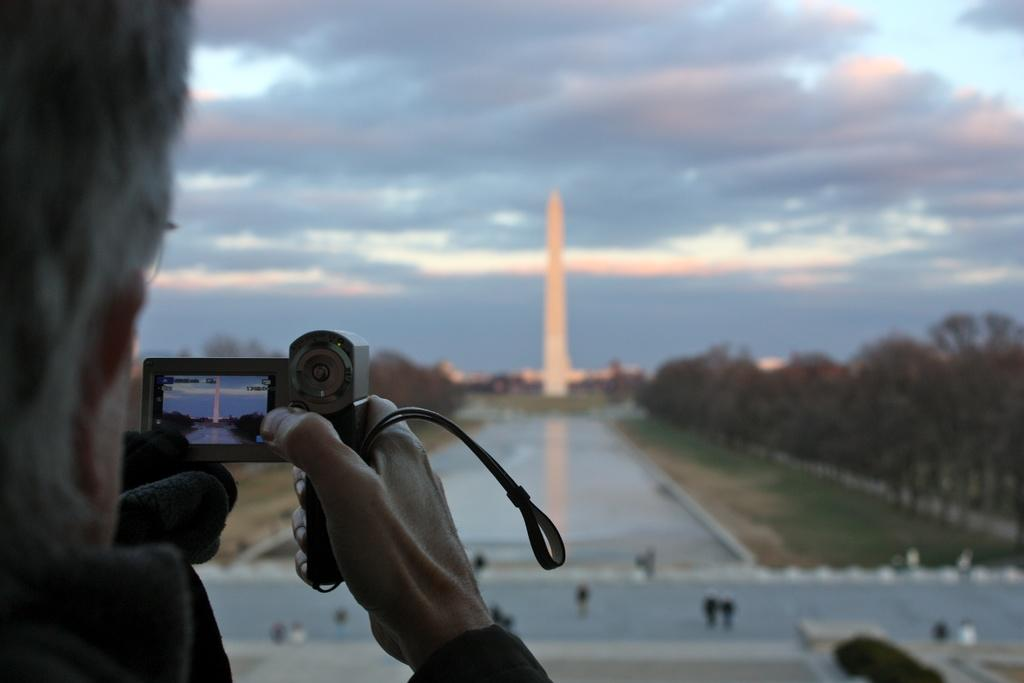What is the person in the image doing? The person is holding a video camera and recording with it. What can be seen in the background of the image? There are trees, a building, and clouds in the sky, which is visible in the background of the image. How many lumber pieces are scattered on the ground in the image? There is no mention of lumber or a ground in the image; it features a person recording with a video camera and a background with trees, a building, clouds, and the sky. 